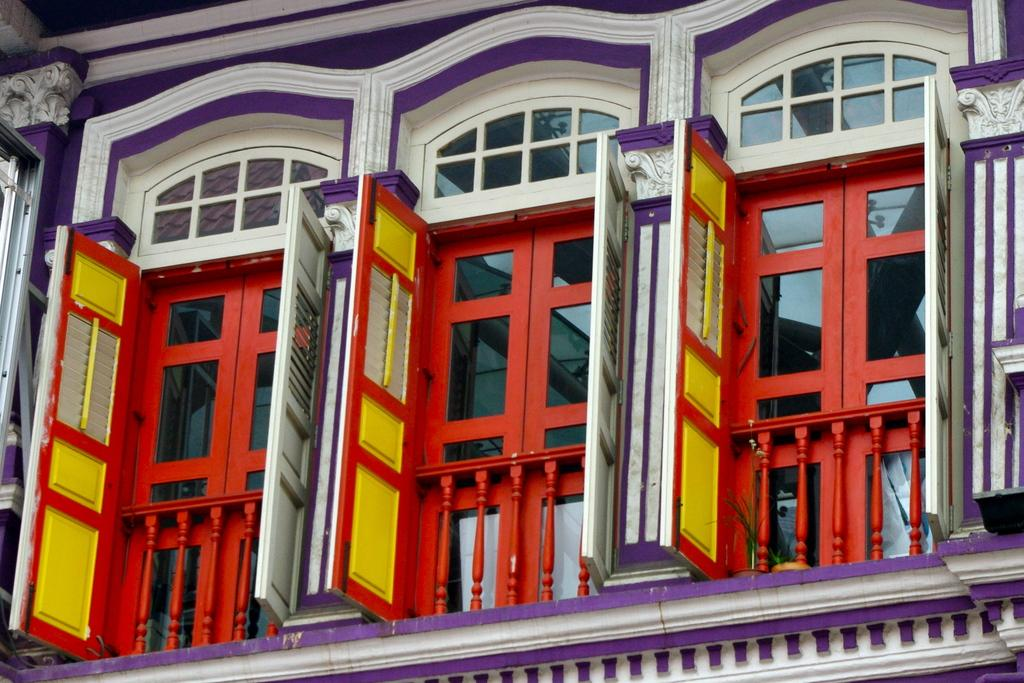What type of structure is present in the image? There is a building in the image. What feature of the building stands out? The building has red color windows. What architectural element is present in the image? The building has a grille. What type of limit is placed on the building in the image? There is no mention of any limit being placed on the building in the image. 